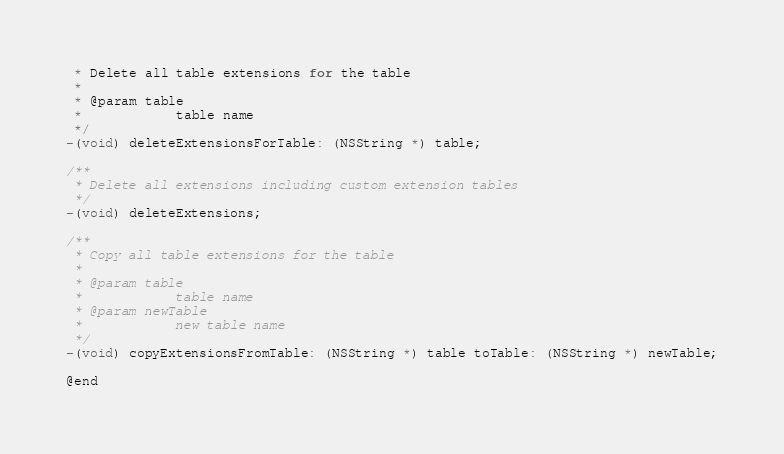Convert code to text. <code><loc_0><loc_0><loc_500><loc_500><_C_> * Delete all table extensions for the table
 *
 * @param table
 *            table name
 */
-(void) deleteExtensionsForTable: (NSString *) table;

/**
 * Delete all extensions including custom extension tables
 */
-(void) deleteExtensions;

/**
 * Copy all table extensions for the table
 *
 * @param table
 *            table name
 * @param newTable
 *            new table name
 */
-(void) copyExtensionsFromTable: (NSString *) table toTable: (NSString *) newTable;

@end
</code> 